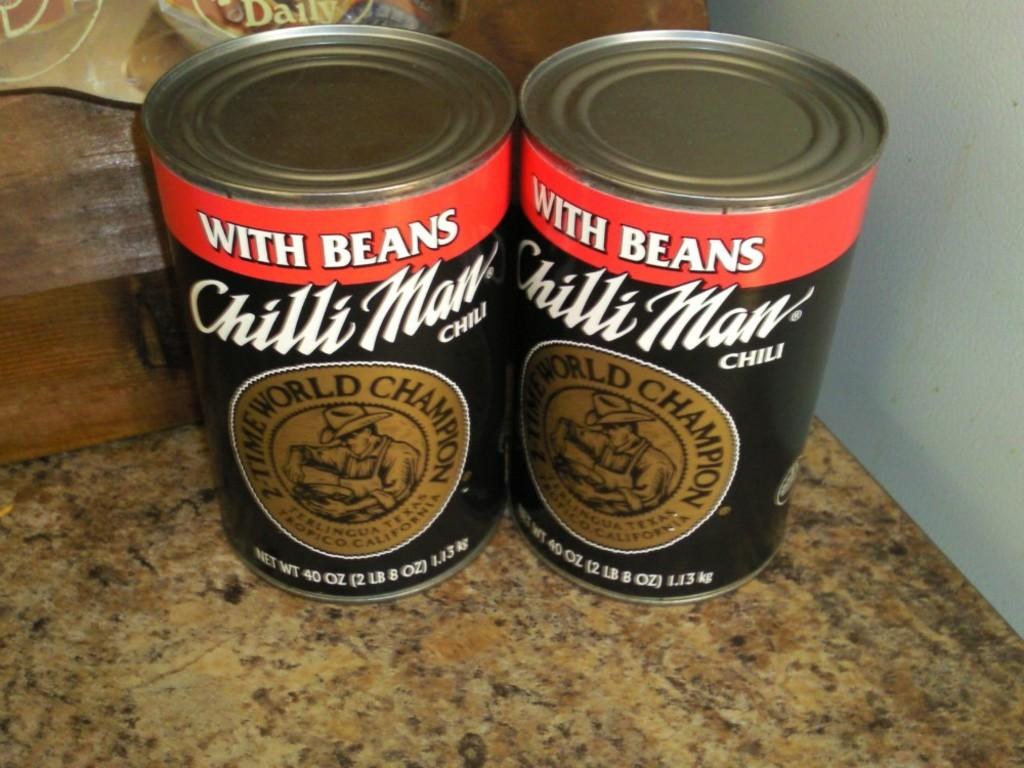How many tins can be seen in the image? There are two tins in the image. What can be found on the tins? There is text written on the tins. Can you describe the background of the image? There are objects in the background of the image. Can you see any signs of pleasure on the island in the image? There is no island present in the image, so it is not possible to determine if there are any signs of pleasure on it. 